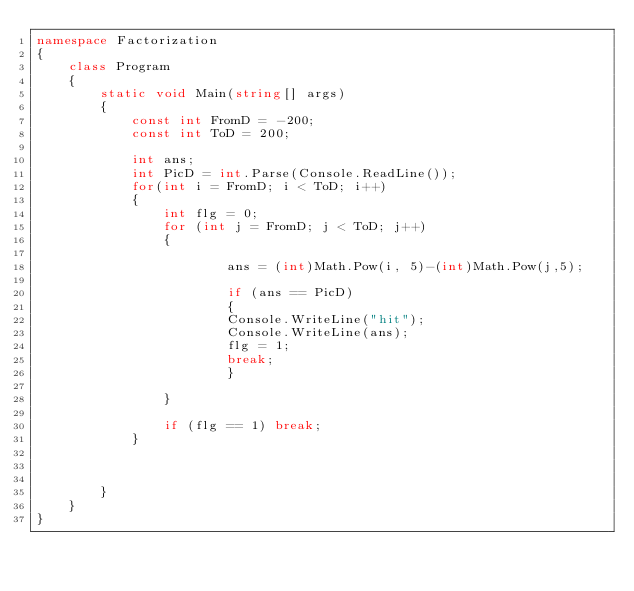<code> <loc_0><loc_0><loc_500><loc_500><_C#_>namespace Factorization
{
    class Program
    {
        static void Main(string[] args)
        {
            const int FromD = -200;
            const int ToD = 200;

            int ans;
            int PicD = int.Parse(Console.ReadLine());
            for(int i = FromD; i < ToD; i++)
            {
                int flg = 0;
                for (int j = FromD; j < ToD; j++)
                {

                        ans = (int)Math.Pow(i, 5)-(int)Math.Pow(j,5);

                        if (ans == PicD)
                        {
                        Console.WriteLine("hit");
                        Console.WriteLine(ans);
                        flg = 1;
                        break;
                        }
 
                }

                if (flg == 1) break;
            }

           
            
        }
    }
}
</code> 